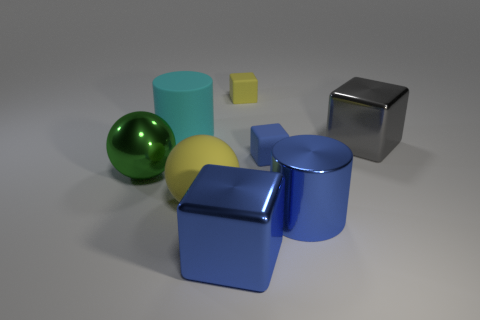Add 1 gray metal cylinders. How many objects exist? 9 Subtract all balls. How many objects are left? 6 Subtract all green metallic balls. Subtract all red metallic blocks. How many objects are left? 7 Add 6 large cubes. How many large cubes are left? 8 Add 3 blue metallic blocks. How many blue metallic blocks exist? 4 Subtract 1 green spheres. How many objects are left? 7 